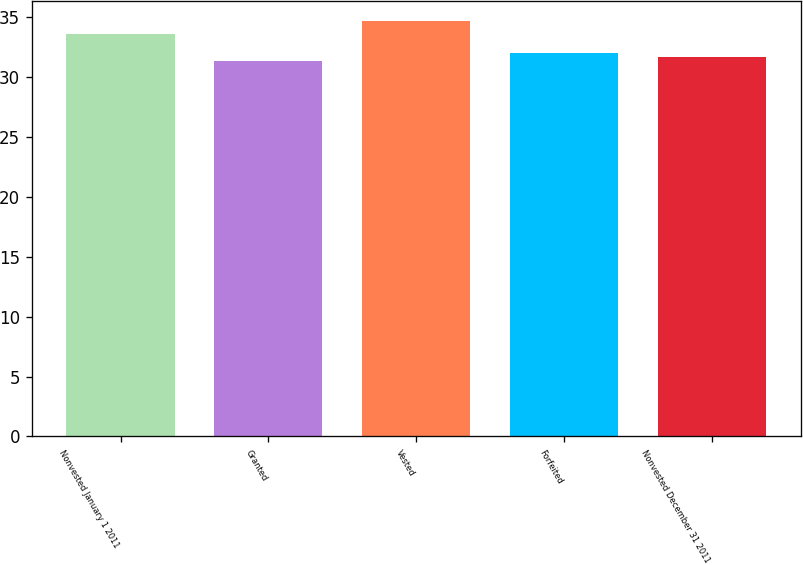Convert chart to OTSL. <chart><loc_0><loc_0><loc_500><loc_500><bar_chart><fcel>Nonvested January 1 2011<fcel>Granted<fcel>Vested<fcel>Forfeited<fcel>Nonvested December 31 2011<nl><fcel>33.58<fcel>31.35<fcel>34.64<fcel>32.01<fcel>31.68<nl></chart> 